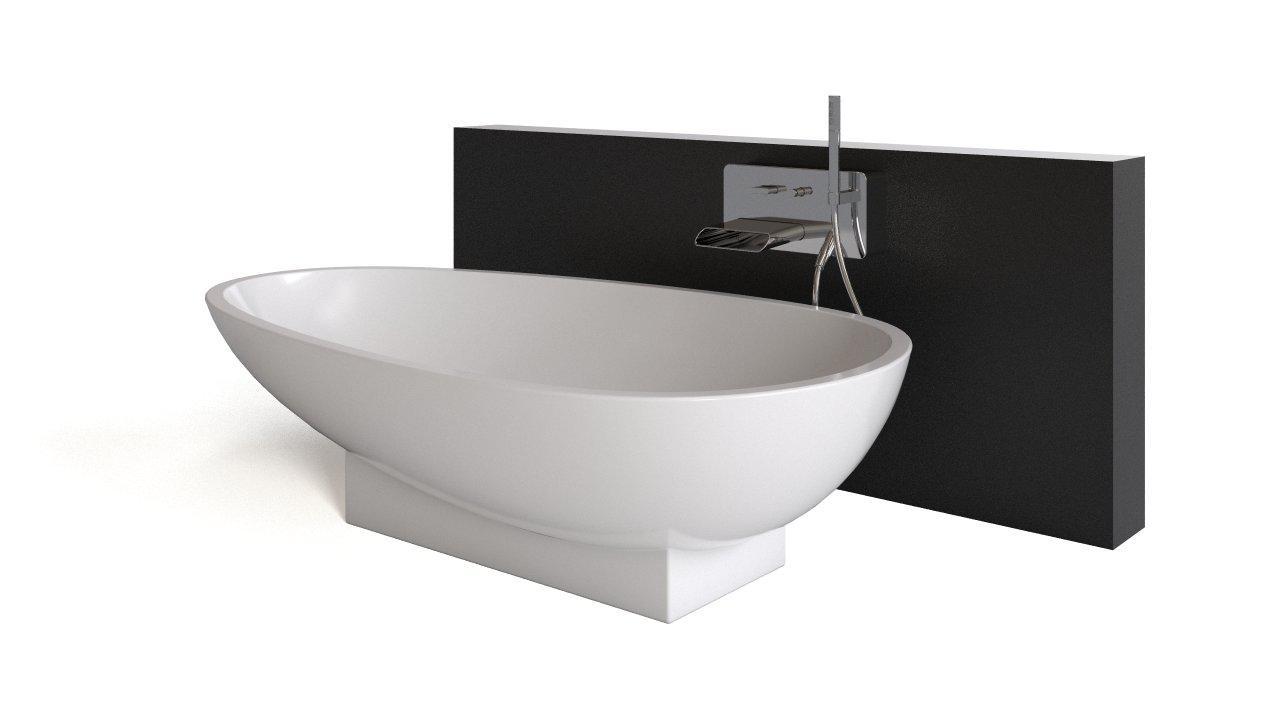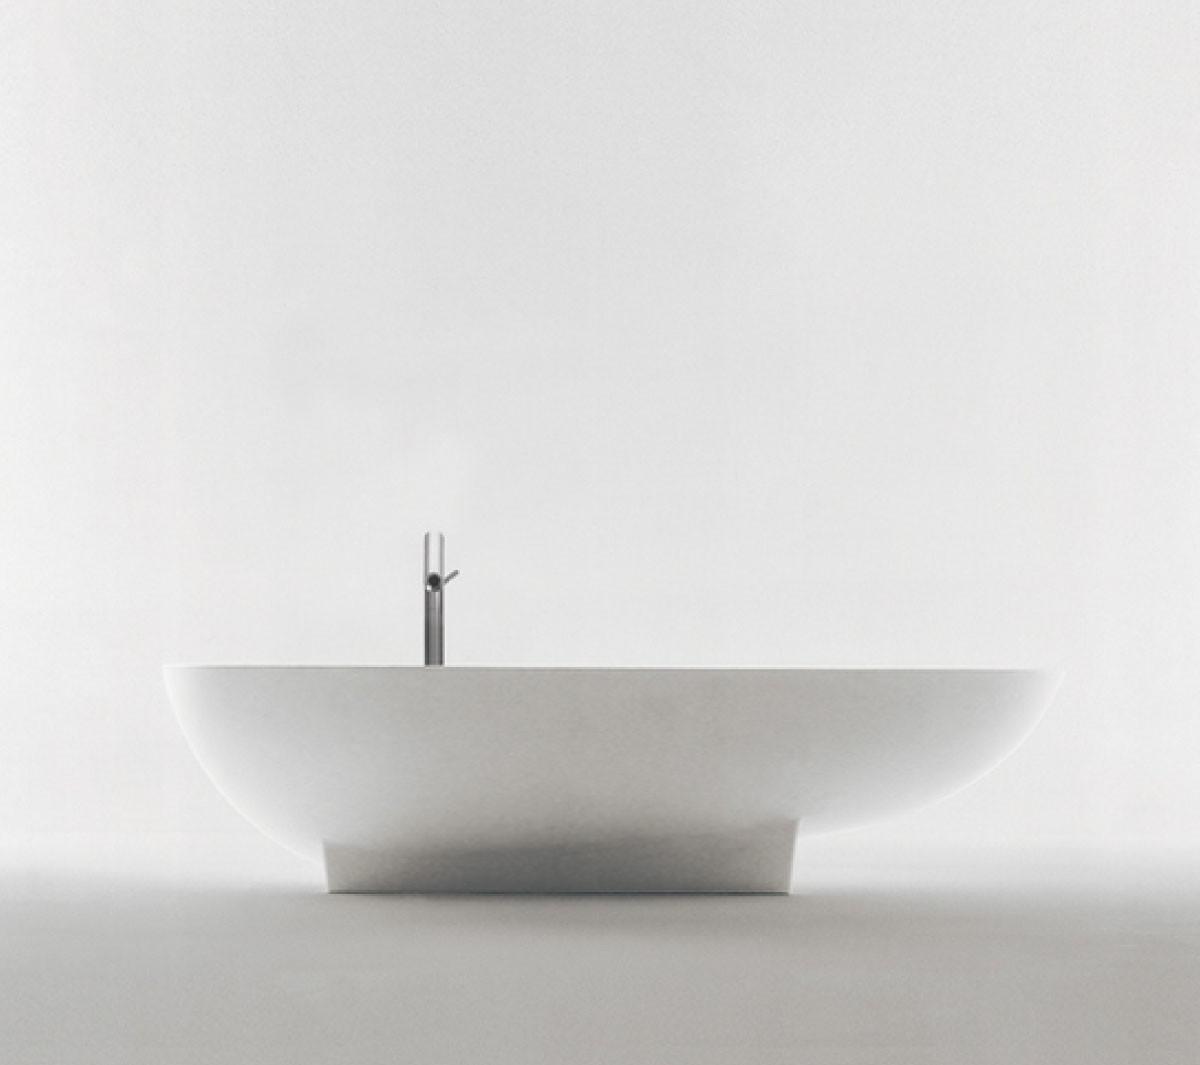The first image is the image on the left, the second image is the image on the right. For the images shown, is this caption "In one of the images, a bar of soap can be seen next to a sink." true? Answer yes or no. No. The first image is the image on the left, the second image is the image on the right. Given the left and right images, does the statement "There are bars of soap on the left side of a wash basin in the right image." hold true? Answer yes or no. No. 